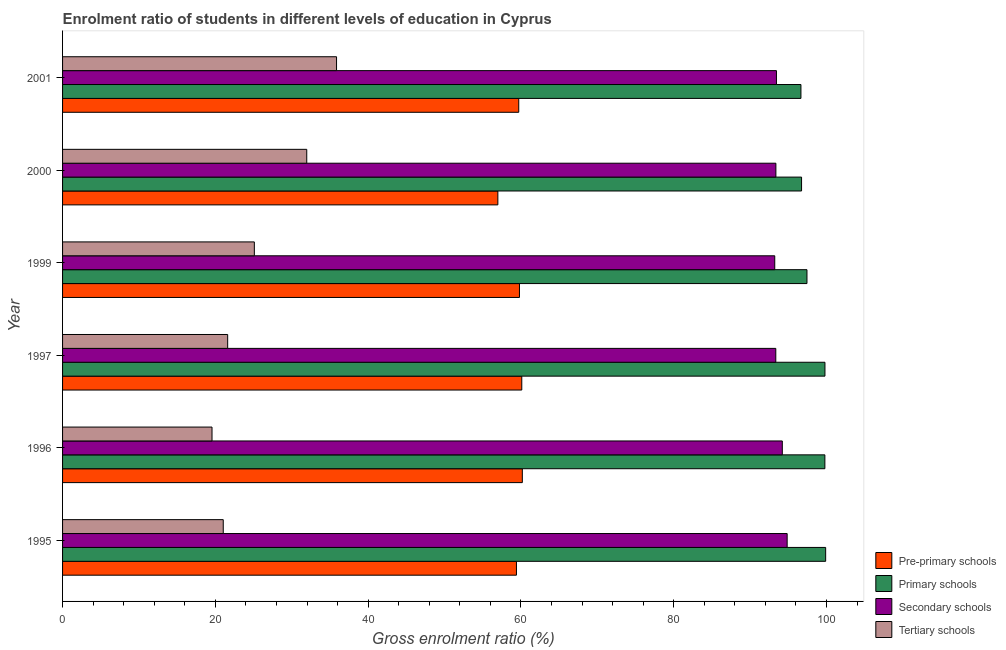How many different coloured bars are there?
Keep it short and to the point. 4. How many groups of bars are there?
Provide a succinct answer. 6. Are the number of bars per tick equal to the number of legend labels?
Provide a short and direct response. Yes. Are the number of bars on each tick of the Y-axis equal?
Keep it short and to the point. Yes. In how many cases, is the number of bars for a given year not equal to the number of legend labels?
Make the answer very short. 0. What is the gross enrolment ratio in pre-primary schools in 1997?
Keep it short and to the point. 60.11. Across all years, what is the maximum gross enrolment ratio in tertiary schools?
Provide a succinct answer. 35.86. Across all years, what is the minimum gross enrolment ratio in tertiary schools?
Offer a very short reply. 19.56. In which year was the gross enrolment ratio in primary schools maximum?
Keep it short and to the point. 1995. What is the total gross enrolment ratio in primary schools in the graph?
Your answer should be very brief. 590.28. What is the difference between the gross enrolment ratio in pre-primary schools in 1997 and that in 2001?
Offer a very short reply. 0.4. What is the difference between the gross enrolment ratio in pre-primary schools in 1999 and the gross enrolment ratio in primary schools in 1996?
Offer a terse response. -39.98. What is the average gross enrolment ratio in secondary schools per year?
Provide a succinct answer. 93.74. In the year 2000, what is the difference between the gross enrolment ratio in primary schools and gross enrolment ratio in pre-primary schools?
Your answer should be compact. 39.75. What is the ratio of the gross enrolment ratio in secondary schools in 1995 to that in 1999?
Keep it short and to the point. 1.02. What is the difference between the highest and the second highest gross enrolment ratio in tertiary schools?
Provide a short and direct response. 3.9. What is the difference between the highest and the lowest gross enrolment ratio in secondary schools?
Ensure brevity in your answer.  1.62. Is the sum of the gross enrolment ratio in tertiary schools in 1996 and 2001 greater than the maximum gross enrolment ratio in pre-primary schools across all years?
Offer a terse response. No. What does the 1st bar from the top in 1996 represents?
Your response must be concise. Tertiary schools. What does the 1st bar from the bottom in 2000 represents?
Offer a terse response. Pre-primary schools. Is it the case that in every year, the sum of the gross enrolment ratio in pre-primary schools and gross enrolment ratio in primary schools is greater than the gross enrolment ratio in secondary schools?
Keep it short and to the point. Yes. Are all the bars in the graph horizontal?
Keep it short and to the point. Yes. Are the values on the major ticks of X-axis written in scientific E-notation?
Give a very brief answer. No. Does the graph contain any zero values?
Keep it short and to the point. No. Where does the legend appear in the graph?
Your response must be concise. Bottom right. How are the legend labels stacked?
Your response must be concise. Vertical. What is the title of the graph?
Make the answer very short. Enrolment ratio of students in different levels of education in Cyprus. What is the label or title of the Y-axis?
Provide a succinct answer. Year. What is the Gross enrolment ratio (%) of Pre-primary schools in 1995?
Offer a terse response. 59.41. What is the Gross enrolment ratio (%) in Primary schools in 1995?
Offer a very short reply. 99.88. What is the Gross enrolment ratio (%) in Secondary schools in 1995?
Offer a very short reply. 94.85. What is the Gross enrolment ratio (%) of Tertiary schools in 1995?
Keep it short and to the point. 21.03. What is the Gross enrolment ratio (%) of Pre-primary schools in 1996?
Your answer should be very brief. 60.18. What is the Gross enrolment ratio (%) of Primary schools in 1996?
Ensure brevity in your answer.  99.78. What is the Gross enrolment ratio (%) of Secondary schools in 1996?
Offer a very short reply. 94.21. What is the Gross enrolment ratio (%) of Tertiary schools in 1996?
Your answer should be compact. 19.56. What is the Gross enrolment ratio (%) of Pre-primary schools in 1997?
Keep it short and to the point. 60.11. What is the Gross enrolment ratio (%) in Primary schools in 1997?
Keep it short and to the point. 99.79. What is the Gross enrolment ratio (%) in Secondary schools in 1997?
Your response must be concise. 93.36. What is the Gross enrolment ratio (%) of Tertiary schools in 1997?
Provide a succinct answer. 21.61. What is the Gross enrolment ratio (%) in Pre-primary schools in 1999?
Your answer should be compact. 59.81. What is the Gross enrolment ratio (%) in Primary schools in 1999?
Keep it short and to the point. 97.44. What is the Gross enrolment ratio (%) in Secondary schools in 1999?
Keep it short and to the point. 93.22. What is the Gross enrolment ratio (%) in Tertiary schools in 1999?
Make the answer very short. 25.1. What is the Gross enrolment ratio (%) of Pre-primary schools in 2000?
Offer a very short reply. 56.98. What is the Gross enrolment ratio (%) in Primary schools in 2000?
Your answer should be very brief. 96.73. What is the Gross enrolment ratio (%) in Secondary schools in 2000?
Provide a short and direct response. 93.37. What is the Gross enrolment ratio (%) in Tertiary schools in 2000?
Keep it short and to the point. 31.96. What is the Gross enrolment ratio (%) in Pre-primary schools in 2001?
Your answer should be compact. 59.71. What is the Gross enrolment ratio (%) in Primary schools in 2001?
Make the answer very short. 96.65. What is the Gross enrolment ratio (%) of Secondary schools in 2001?
Provide a succinct answer. 93.45. What is the Gross enrolment ratio (%) in Tertiary schools in 2001?
Keep it short and to the point. 35.86. Across all years, what is the maximum Gross enrolment ratio (%) of Pre-primary schools?
Offer a very short reply. 60.18. Across all years, what is the maximum Gross enrolment ratio (%) in Primary schools?
Give a very brief answer. 99.88. Across all years, what is the maximum Gross enrolment ratio (%) in Secondary schools?
Ensure brevity in your answer.  94.85. Across all years, what is the maximum Gross enrolment ratio (%) of Tertiary schools?
Offer a terse response. 35.86. Across all years, what is the minimum Gross enrolment ratio (%) of Pre-primary schools?
Offer a terse response. 56.98. Across all years, what is the minimum Gross enrolment ratio (%) of Primary schools?
Your response must be concise. 96.65. Across all years, what is the minimum Gross enrolment ratio (%) of Secondary schools?
Ensure brevity in your answer.  93.22. Across all years, what is the minimum Gross enrolment ratio (%) in Tertiary schools?
Provide a succinct answer. 19.56. What is the total Gross enrolment ratio (%) of Pre-primary schools in the graph?
Offer a terse response. 356.2. What is the total Gross enrolment ratio (%) in Primary schools in the graph?
Ensure brevity in your answer.  590.28. What is the total Gross enrolment ratio (%) of Secondary schools in the graph?
Your answer should be very brief. 562.46. What is the total Gross enrolment ratio (%) of Tertiary schools in the graph?
Keep it short and to the point. 155.14. What is the difference between the Gross enrolment ratio (%) in Pre-primary schools in 1995 and that in 1996?
Provide a succinct answer. -0.77. What is the difference between the Gross enrolment ratio (%) of Primary schools in 1995 and that in 1996?
Provide a succinct answer. 0.1. What is the difference between the Gross enrolment ratio (%) of Secondary schools in 1995 and that in 1996?
Your answer should be very brief. 0.63. What is the difference between the Gross enrolment ratio (%) of Tertiary schools in 1995 and that in 1996?
Provide a succinct answer. 1.47. What is the difference between the Gross enrolment ratio (%) in Pre-primary schools in 1995 and that in 1997?
Keep it short and to the point. -0.7. What is the difference between the Gross enrolment ratio (%) in Primary schools in 1995 and that in 1997?
Offer a very short reply. 0.09. What is the difference between the Gross enrolment ratio (%) in Secondary schools in 1995 and that in 1997?
Provide a short and direct response. 1.49. What is the difference between the Gross enrolment ratio (%) of Tertiary schools in 1995 and that in 1997?
Offer a terse response. -0.58. What is the difference between the Gross enrolment ratio (%) in Pre-primary schools in 1995 and that in 1999?
Provide a short and direct response. -0.4. What is the difference between the Gross enrolment ratio (%) in Primary schools in 1995 and that in 1999?
Your answer should be very brief. 2.45. What is the difference between the Gross enrolment ratio (%) of Secondary schools in 1995 and that in 1999?
Your response must be concise. 1.62. What is the difference between the Gross enrolment ratio (%) of Tertiary schools in 1995 and that in 1999?
Your response must be concise. -4.07. What is the difference between the Gross enrolment ratio (%) of Pre-primary schools in 1995 and that in 2000?
Your answer should be compact. 2.43. What is the difference between the Gross enrolment ratio (%) of Primary schools in 1995 and that in 2000?
Your answer should be very brief. 3.15. What is the difference between the Gross enrolment ratio (%) of Secondary schools in 1995 and that in 2000?
Your answer should be very brief. 1.47. What is the difference between the Gross enrolment ratio (%) of Tertiary schools in 1995 and that in 2000?
Make the answer very short. -10.93. What is the difference between the Gross enrolment ratio (%) of Pre-primary schools in 1995 and that in 2001?
Your answer should be compact. -0.3. What is the difference between the Gross enrolment ratio (%) in Primary schools in 1995 and that in 2001?
Keep it short and to the point. 3.23. What is the difference between the Gross enrolment ratio (%) of Secondary schools in 1995 and that in 2001?
Keep it short and to the point. 1.4. What is the difference between the Gross enrolment ratio (%) of Tertiary schools in 1995 and that in 2001?
Your answer should be compact. -14.83. What is the difference between the Gross enrolment ratio (%) of Pre-primary schools in 1996 and that in 1997?
Your answer should be very brief. 0.07. What is the difference between the Gross enrolment ratio (%) in Primary schools in 1996 and that in 1997?
Offer a very short reply. -0.01. What is the difference between the Gross enrolment ratio (%) in Secondary schools in 1996 and that in 1997?
Your answer should be compact. 0.85. What is the difference between the Gross enrolment ratio (%) of Tertiary schools in 1996 and that in 1997?
Provide a succinct answer. -2.05. What is the difference between the Gross enrolment ratio (%) of Pre-primary schools in 1996 and that in 1999?
Your answer should be compact. 0.37. What is the difference between the Gross enrolment ratio (%) of Primary schools in 1996 and that in 1999?
Make the answer very short. 2.35. What is the difference between the Gross enrolment ratio (%) of Tertiary schools in 1996 and that in 1999?
Provide a short and direct response. -5.54. What is the difference between the Gross enrolment ratio (%) of Pre-primary schools in 1996 and that in 2000?
Ensure brevity in your answer.  3.2. What is the difference between the Gross enrolment ratio (%) in Primary schools in 1996 and that in 2000?
Ensure brevity in your answer.  3.05. What is the difference between the Gross enrolment ratio (%) of Secondary schools in 1996 and that in 2000?
Provide a succinct answer. 0.84. What is the difference between the Gross enrolment ratio (%) of Tertiary schools in 1996 and that in 2000?
Your answer should be compact. -12.4. What is the difference between the Gross enrolment ratio (%) of Pre-primary schools in 1996 and that in 2001?
Ensure brevity in your answer.  0.47. What is the difference between the Gross enrolment ratio (%) of Primary schools in 1996 and that in 2001?
Offer a terse response. 3.13. What is the difference between the Gross enrolment ratio (%) of Secondary schools in 1996 and that in 2001?
Offer a very short reply. 0.77. What is the difference between the Gross enrolment ratio (%) in Tertiary schools in 1996 and that in 2001?
Your answer should be very brief. -16.3. What is the difference between the Gross enrolment ratio (%) of Pre-primary schools in 1997 and that in 1999?
Ensure brevity in your answer.  0.3. What is the difference between the Gross enrolment ratio (%) of Primary schools in 1997 and that in 1999?
Provide a short and direct response. 2.35. What is the difference between the Gross enrolment ratio (%) of Secondary schools in 1997 and that in 1999?
Ensure brevity in your answer.  0.14. What is the difference between the Gross enrolment ratio (%) of Tertiary schools in 1997 and that in 1999?
Your answer should be compact. -3.49. What is the difference between the Gross enrolment ratio (%) in Pre-primary schools in 1997 and that in 2000?
Offer a very short reply. 3.13. What is the difference between the Gross enrolment ratio (%) in Primary schools in 1997 and that in 2000?
Your answer should be compact. 3.06. What is the difference between the Gross enrolment ratio (%) in Secondary schools in 1997 and that in 2000?
Give a very brief answer. -0.01. What is the difference between the Gross enrolment ratio (%) of Tertiary schools in 1997 and that in 2000?
Offer a terse response. -10.35. What is the difference between the Gross enrolment ratio (%) in Pre-primary schools in 1997 and that in 2001?
Keep it short and to the point. 0.4. What is the difference between the Gross enrolment ratio (%) of Primary schools in 1997 and that in 2001?
Keep it short and to the point. 3.14. What is the difference between the Gross enrolment ratio (%) of Secondary schools in 1997 and that in 2001?
Make the answer very short. -0.09. What is the difference between the Gross enrolment ratio (%) in Tertiary schools in 1997 and that in 2001?
Your answer should be compact. -14.25. What is the difference between the Gross enrolment ratio (%) of Pre-primary schools in 1999 and that in 2000?
Give a very brief answer. 2.83. What is the difference between the Gross enrolment ratio (%) in Primary schools in 1999 and that in 2000?
Make the answer very short. 0.71. What is the difference between the Gross enrolment ratio (%) of Secondary schools in 1999 and that in 2000?
Provide a short and direct response. -0.15. What is the difference between the Gross enrolment ratio (%) in Tertiary schools in 1999 and that in 2000?
Offer a very short reply. -6.86. What is the difference between the Gross enrolment ratio (%) of Pre-primary schools in 1999 and that in 2001?
Offer a terse response. 0.09. What is the difference between the Gross enrolment ratio (%) of Primary schools in 1999 and that in 2001?
Your answer should be very brief. 0.79. What is the difference between the Gross enrolment ratio (%) in Secondary schools in 1999 and that in 2001?
Give a very brief answer. -0.22. What is the difference between the Gross enrolment ratio (%) in Tertiary schools in 1999 and that in 2001?
Offer a very short reply. -10.76. What is the difference between the Gross enrolment ratio (%) of Pre-primary schools in 2000 and that in 2001?
Keep it short and to the point. -2.74. What is the difference between the Gross enrolment ratio (%) in Primary schools in 2000 and that in 2001?
Provide a succinct answer. 0.08. What is the difference between the Gross enrolment ratio (%) in Secondary schools in 2000 and that in 2001?
Provide a succinct answer. -0.07. What is the difference between the Gross enrolment ratio (%) in Tertiary schools in 2000 and that in 2001?
Your response must be concise. -3.9. What is the difference between the Gross enrolment ratio (%) of Pre-primary schools in 1995 and the Gross enrolment ratio (%) of Primary schools in 1996?
Provide a short and direct response. -40.37. What is the difference between the Gross enrolment ratio (%) in Pre-primary schools in 1995 and the Gross enrolment ratio (%) in Secondary schools in 1996?
Provide a succinct answer. -34.8. What is the difference between the Gross enrolment ratio (%) of Pre-primary schools in 1995 and the Gross enrolment ratio (%) of Tertiary schools in 1996?
Provide a succinct answer. 39.85. What is the difference between the Gross enrolment ratio (%) in Primary schools in 1995 and the Gross enrolment ratio (%) in Secondary schools in 1996?
Give a very brief answer. 5.67. What is the difference between the Gross enrolment ratio (%) in Primary schools in 1995 and the Gross enrolment ratio (%) in Tertiary schools in 1996?
Provide a succinct answer. 80.32. What is the difference between the Gross enrolment ratio (%) in Secondary schools in 1995 and the Gross enrolment ratio (%) in Tertiary schools in 1996?
Offer a very short reply. 75.28. What is the difference between the Gross enrolment ratio (%) in Pre-primary schools in 1995 and the Gross enrolment ratio (%) in Primary schools in 1997?
Give a very brief answer. -40.38. What is the difference between the Gross enrolment ratio (%) in Pre-primary schools in 1995 and the Gross enrolment ratio (%) in Secondary schools in 1997?
Your answer should be compact. -33.95. What is the difference between the Gross enrolment ratio (%) of Pre-primary schools in 1995 and the Gross enrolment ratio (%) of Tertiary schools in 1997?
Provide a short and direct response. 37.8. What is the difference between the Gross enrolment ratio (%) in Primary schools in 1995 and the Gross enrolment ratio (%) in Secondary schools in 1997?
Your answer should be very brief. 6.53. What is the difference between the Gross enrolment ratio (%) in Primary schools in 1995 and the Gross enrolment ratio (%) in Tertiary schools in 1997?
Your answer should be compact. 78.27. What is the difference between the Gross enrolment ratio (%) in Secondary schools in 1995 and the Gross enrolment ratio (%) in Tertiary schools in 1997?
Keep it short and to the point. 73.23. What is the difference between the Gross enrolment ratio (%) in Pre-primary schools in 1995 and the Gross enrolment ratio (%) in Primary schools in 1999?
Make the answer very short. -38.03. What is the difference between the Gross enrolment ratio (%) in Pre-primary schools in 1995 and the Gross enrolment ratio (%) in Secondary schools in 1999?
Provide a short and direct response. -33.81. What is the difference between the Gross enrolment ratio (%) of Pre-primary schools in 1995 and the Gross enrolment ratio (%) of Tertiary schools in 1999?
Ensure brevity in your answer.  34.31. What is the difference between the Gross enrolment ratio (%) in Primary schools in 1995 and the Gross enrolment ratio (%) in Secondary schools in 1999?
Provide a succinct answer. 6.66. What is the difference between the Gross enrolment ratio (%) in Primary schools in 1995 and the Gross enrolment ratio (%) in Tertiary schools in 1999?
Give a very brief answer. 74.78. What is the difference between the Gross enrolment ratio (%) in Secondary schools in 1995 and the Gross enrolment ratio (%) in Tertiary schools in 1999?
Your response must be concise. 69.74. What is the difference between the Gross enrolment ratio (%) in Pre-primary schools in 1995 and the Gross enrolment ratio (%) in Primary schools in 2000?
Ensure brevity in your answer.  -37.32. What is the difference between the Gross enrolment ratio (%) in Pre-primary schools in 1995 and the Gross enrolment ratio (%) in Secondary schools in 2000?
Offer a very short reply. -33.96. What is the difference between the Gross enrolment ratio (%) of Pre-primary schools in 1995 and the Gross enrolment ratio (%) of Tertiary schools in 2000?
Keep it short and to the point. 27.45. What is the difference between the Gross enrolment ratio (%) in Primary schools in 1995 and the Gross enrolment ratio (%) in Secondary schools in 2000?
Ensure brevity in your answer.  6.51. What is the difference between the Gross enrolment ratio (%) in Primary schools in 1995 and the Gross enrolment ratio (%) in Tertiary schools in 2000?
Your answer should be compact. 67.92. What is the difference between the Gross enrolment ratio (%) in Secondary schools in 1995 and the Gross enrolment ratio (%) in Tertiary schools in 2000?
Provide a succinct answer. 62.88. What is the difference between the Gross enrolment ratio (%) of Pre-primary schools in 1995 and the Gross enrolment ratio (%) of Primary schools in 2001?
Give a very brief answer. -37.24. What is the difference between the Gross enrolment ratio (%) in Pre-primary schools in 1995 and the Gross enrolment ratio (%) in Secondary schools in 2001?
Keep it short and to the point. -34.03. What is the difference between the Gross enrolment ratio (%) in Pre-primary schools in 1995 and the Gross enrolment ratio (%) in Tertiary schools in 2001?
Your answer should be compact. 23.55. What is the difference between the Gross enrolment ratio (%) in Primary schools in 1995 and the Gross enrolment ratio (%) in Secondary schools in 2001?
Your answer should be compact. 6.44. What is the difference between the Gross enrolment ratio (%) in Primary schools in 1995 and the Gross enrolment ratio (%) in Tertiary schools in 2001?
Your answer should be very brief. 64.02. What is the difference between the Gross enrolment ratio (%) in Secondary schools in 1995 and the Gross enrolment ratio (%) in Tertiary schools in 2001?
Keep it short and to the point. 58.98. What is the difference between the Gross enrolment ratio (%) of Pre-primary schools in 1996 and the Gross enrolment ratio (%) of Primary schools in 1997?
Offer a terse response. -39.61. What is the difference between the Gross enrolment ratio (%) of Pre-primary schools in 1996 and the Gross enrolment ratio (%) of Secondary schools in 1997?
Provide a succinct answer. -33.18. What is the difference between the Gross enrolment ratio (%) in Pre-primary schools in 1996 and the Gross enrolment ratio (%) in Tertiary schools in 1997?
Give a very brief answer. 38.57. What is the difference between the Gross enrolment ratio (%) of Primary schools in 1996 and the Gross enrolment ratio (%) of Secondary schools in 1997?
Ensure brevity in your answer.  6.42. What is the difference between the Gross enrolment ratio (%) of Primary schools in 1996 and the Gross enrolment ratio (%) of Tertiary schools in 1997?
Make the answer very short. 78.17. What is the difference between the Gross enrolment ratio (%) of Secondary schools in 1996 and the Gross enrolment ratio (%) of Tertiary schools in 1997?
Offer a terse response. 72.6. What is the difference between the Gross enrolment ratio (%) of Pre-primary schools in 1996 and the Gross enrolment ratio (%) of Primary schools in 1999?
Your response must be concise. -37.26. What is the difference between the Gross enrolment ratio (%) of Pre-primary schools in 1996 and the Gross enrolment ratio (%) of Secondary schools in 1999?
Make the answer very short. -33.04. What is the difference between the Gross enrolment ratio (%) of Pre-primary schools in 1996 and the Gross enrolment ratio (%) of Tertiary schools in 1999?
Your answer should be compact. 35.08. What is the difference between the Gross enrolment ratio (%) of Primary schools in 1996 and the Gross enrolment ratio (%) of Secondary schools in 1999?
Your answer should be compact. 6.56. What is the difference between the Gross enrolment ratio (%) in Primary schools in 1996 and the Gross enrolment ratio (%) in Tertiary schools in 1999?
Your answer should be compact. 74.68. What is the difference between the Gross enrolment ratio (%) in Secondary schools in 1996 and the Gross enrolment ratio (%) in Tertiary schools in 1999?
Your response must be concise. 69.11. What is the difference between the Gross enrolment ratio (%) of Pre-primary schools in 1996 and the Gross enrolment ratio (%) of Primary schools in 2000?
Provide a short and direct response. -36.55. What is the difference between the Gross enrolment ratio (%) of Pre-primary schools in 1996 and the Gross enrolment ratio (%) of Secondary schools in 2000?
Your response must be concise. -33.19. What is the difference between the Gross enrolment ratio (%) of Pre-primary schools in 1996 and the Gross enrolment ratio (%) of Tertiary schools in 2000?
Keep it short and to the point. 28.22. What is the difference between the Gross enrolment ratio (%) of Primary schools in 1996 and the Gross enrolment ratio (%) of Secondary schools in 2000?
Keep it short and to the point. 6.41. What is the difference between the Gross enrolment ratio (%) of Primary schools in 1996 and the Gross enrolment ratio (%) of Tertiary schools in 2000?
Your response must be concise. 67.82. What is the difference between the Gross enrolment ratio (%) in Secondary schools in 1996 and the Gross enrolment ratio (%) in Tertiary schools in 2000?
Offer a terse response. 62.25. What is the difference between the Gross enrolment ratio (%) in Pre-primary schools in 1996 and the Gross enrolment ratio (%) in Primary schools in 2001?
Your response must be concise. -36.47. What is the difference between the Gross enrolment ratio (%) in Pre-primary schools in 1996 and the Gross enrolment ratio (%) in Secondary schools in 2001?
Offer a very short reply. -33.26. What is the difference between the Gross enrolment ratio (%) in Pre-primary schools in 1996 and the Gross enrolment ratio (%) in Tertiary schools in 2001?
Make the answer very short. 24.32. What is the difference between the Gross enrolment ratio (%) in Primary schools in 1996 and the Gross enrolment ratio (%) in Secondary schools in 2001?
Your answer should be compact. 6.34. What is the difference between the Gross enrolment ratio (%) in Primary schools in 1996 and the Gross enrolment ratio (%) in Tertiary schools in 2001?
Keep it short and to the point. 63.92. What is the difference between the Gross enrolment ratio (%) of Secondary schools in 1996 and the Gross enrolment ratio (%) of Tertiary schools in 2001?
Give a very brief answer. 58.35. What is the difference between the Gross enrolment ratio (%) in Pre-primary schools in 1997 and the Gross enrolment ratio (%) in Primary schools in 1999?
Ensure brevity in your answer.  -37.33. What is the difference between the Gross enrolment ratio (%) in Pre-primary schools in 1997 and the Gross enrolment ratio (%) in Secondary schools in 1999?
Ensure brevity in your answer.  -33.11. What is the difference between the Gross enrolment ratio (%) of Pre-primary schools in 1997 and the Gross enrolment ratio (%) of Tertiary schools in 1999?
Make the answer very short. 35.01. What is the difference between the Gross enrolment ratio (%) of Primary schools in 1997 and the Gross enrolment ratio (%) of Secondary schools in 1999?
Make the answer very short. 6.57. What is the difference between the Gross enrolment ratio (%) in Primary schools in 1997 and the Gross enrolment ratio (%) in Tertiary schools in 1999?
Keep it short and to the point. 74.69. What is the difference between the Gross enrolment ratio (%) in Secondary schools in 1997 and the Gross enrolment ratio (%) in Tertiary schools in 1999?
Ensure brevity in your answer.  68.26. What is the difference between the Gross enrolment ratio (%) of Pre-primary schools in 1997 and the Gross enrolment ratio (%) of Primary schools in 2000?
Your answer should be compact. -36.62. What is the difference between the Gross enrolment ratio (%) of Pre-primary schools in 1997 and the Gross enrolment ratio (%) of Secondary schools in 2000?
Make the answer very short. -33.26. What is the difference between the Gross enrolment ratio (%) in Pre-primary schools in 1997 and the Gross enrolment ratio (%) in Tertiary schools in 2000?
Give a very brief answer. 28.15. What is the difference between the Gross enrolment ratio (%) of Primary schools in 1997 and the Gross enrolment ratio (%) of Secondary schools in 2000?
Offer a terse response. 6.42. What is the difference between the Gross enrolment ratio (%) in Primary schools in 1997 and the Gross enrolment ratio (%) in Tertiary schools in 2000?
Your answer should be compact. 67.83. What is the difference between the Gross enrolment ratio (%) in Secondary schools in 1997 and the Gross enrolment ratio (%) in Tertiary schools in 2000?
Provide a short and direct response. 61.4. What is the difference between the Gross enrolment ratio (%) in Pre-primary schools in 1997 and the Gross enrolment ratio (%) in Primary schools in 2001?
Make the answer very short. -36.54. What is the difference between the Gross enrolment ratio (%) in Pre-primary schools in 1997 and the Gross enrolment ratio (%) in Secondary schools in 2001?
Make the answer very short. -33.34. What is the difference between the Gross enrolment ratio (%) of Pre-primary schools in 1997 and the Gross enrolment ratio (%) of Tertiary schools in 2001?
Your response must be concise. 24.25. What is the difference between the Gross enrolment ratio (%) of Primary schools in 1997 and the Gross enrolment ratio (%) of Secondary schools in 2001?
Make the answer very short. 6.35. What is the difference between the Gross enrolment ratio (%) of Primary schools in 1997 and the Gross enrolment ratio (%) of Tertiary schools in 2001?
Your response must be concise. 63.93. What is the difference between the Gross enrolment ratio (%) of Secondary schools in 1997 and the Gross enrolment ratio (%) of Tertiary schools in 2001?
Provide a short and direct response. 57.5. What is the difference between the Gross enrolment ratio (%) in Pre-primary schools in 1999 and the Gross enrolment ratio (%) in Primary schools in 2000?
Provide a succinct answer. -36.92. What is the difference between the Gross enrolment ratio (%) of Pre-primary schools in 1999 and the Gross enrolment ratio (%) of Secondary schools in 2000?
Your answer should be compact. -33.56. What is the difference between the Gross enrolment ratio (%) in Pre-primary schools in 1999 and the Gross enrolment ratio (%) in Tertiary schools in 2000?
Make the answer very short. 27.84. What is the difference between the Gross enrolment ratio (%) in Primary schools in 1999 and the Gross enrolment ratio (%) in Secondary schools in 2000?
Offer a terse response. 4.07. What is the difference between the Gross enrolment ratio (%) of Primary schools in 1999 and the Gross enrolment ratio (%) of Tertiary schools in 2000?
Keep it short and to the point. 65.47. What is the difference between the Gross enrolment ratio (%) of Secondary schools in 1999 and the Gross enrolment ratio (%) of Tertiary schools in 2000?
Provide a succinct answer. 61.26. What is the difference between the Gross enrolment ratio (%) in Pre-primary schools in 1999 and the Gross enrolment ratio (%) in Primary schools in 2001?
Your response must be concise. -36.84. What is the difference between the Gross enrolment ratio (%) of Pre-primary schools in 1999 and the Gross enrolment ratio (%) of Secondary schools in 2001?
Offer a terse response. -33.64. What is the difference between the Gross enrolment ratio (%) in Pre-primary schools in 1999 and the Gross enrolment ratio (%) in Tertiary schools in 2001?
Provide a succinct answer. 23.94. What is the difference between the Gross enrolment ratio (%) of Primary schools in 1999 and the Gross enrolment ratio (%) of Secondary schools in 2001?
Your answer should be very brief. 3.99. What is the difference between the Gross enrolment ratio (%) of Primary schools in 1999 and the Gross enrolment ratio (%) of Tertiary schools in 2001?
Offer a very short reply. 61.57. What is the difference between the Gross enrolment ratio (%) in Secondary schools in 1999 and the Gross enrolment ratio (%) in Tertiary schools in 2001?
Your response must be concise. 57.36. What is the difference between the Gross enrolment ratio (%) of Pre-primary schools in 2000 and the Gross enrolment ratio (%) of Primary schools in 2001?
Keep it short and to the point. -39.67. What is the difference between the Gross enrolment ratio (%) in Pre-primary schools in 2000 and the Gross enrolment ratio (%) in Secondary schools in 2001?
Make the answer very short. -36.47. What is the difference between the Gross enrolment ratio (%) of Pre-primary schools in 2000 and the Gross enrolment ratio (%) of Tertiary schools in 2001?
Give a very brief answer. 21.11. What is the difference between the Gross enrolment ratio (%) in Primary schools in 2000 and the Gross enrolment ratio (%) in Secondary schools in 2001?
Offer a terse response. 3.29. What is the difference between the Gross enrolment ratio (%) of Primary schools in 2000 and the Gross enrolment ratio (%) of Tertiary schools in 2001?
Give a very brief answer. 60.87. What is the difference between the Gross enrolment ratio (%) in Secondary schools in 2000 and the Gross enrolment ratio (%) in Tertiary schools in 2001?
Your answer should be compact. 57.51. What is the average Gross enrolment ratio (%) of Pre-primary schools per year?
Offer a terse response. 59.37. What is the average Gross enrolment ratio (%) in Primary schools per year?
Offer a very short reply. 98.38. What is the average Gross enrolment ratio (%) of Secondary schools per year?
Your response must be concise. 93.74. What is the average Gross enrolment ratio (%) in Tertiary schools per year?
Offer a very short reply. 25.86. In the year 1995, what is the difference between the Gross enrolment ratio (%) of Pre-primary schools and Gross enrolment ratio (%) of Primary schools?
Provide a succinct answer. -40.47. In the year 1995, what is the difference between the Gross enrolment ratio (%) of Pre-primary schools and Gross enrolment ratio (%) of Secondary schools?
Offer a terse response. -35.43. In the year 1995, what is the difference between the Gross enrolment ratio (%) of Pre-primary schools and Gross enrolment ratio (%) of Tertiary schools?
Keep it short and to the point. 38.38. In the year 1995, what is the difference between the Gross enrolment ratio (%) in Primary schools and Gross enrolment ratio (%) in Secondary schools?
Provide a short and direct response. 5.04. In the year 1995, what is the difference between the Gross enrolment ratio (%) in Primary schools and Gross enrolment ratio (%) in Tertiary schools?
Your answer should be compact. 78.85. In the year 1995, what is the difference between the Gross enrolment ratio (%) in Secondary schools and Gross enrolment ratio (%) in Tertiary schools?
Your answer should be very brief. 73.81. In the year 1996, what is the difference between the Gross enrolment ratio (%) in Pre-primary schools and Gross enrolment ratio (%) in Primary schools?
Keep it short and to the point. -39.6. In the year 1996, what is the difference between the Gross enrolment ratio (%) in Pre-primary schools and Gross enrolment ratio (%) in Secondary schools?
Your answer should be very brief. -34.03. In the year 1996, what is the difference between the Gross enrolment ratio (%) of Pre-primary schools and Gross enrolment ratio (%) of Tertiary schools?
Make the answer very short. 40.62. In the year 1996, what is the difference between the Gross enrolment ratio (%) in Primary schools and Gross enrolment ratio (%) in Secondary schools?
Offer a terse response. 5.57. In the year 1996, what is the difference between the Gross enrolment ratio (%) in Primary schools and Gross enrolment ratio (%) in Tertiary schools?
Offer a terse response. 80.22. In the year 1996, what is the difference between the Gross enrolment ratio (%) in Secondary schools and Gross enrolment ratio (%) in Tertiary schools?
Your answer should be very brief. 74.65. In the year 1997, what is the difference between the Gross enrolment ratio (%) in Pre-primary schools and Gross enrolment ratio (%) in Primary schools?
Ensure brevity in your answer.  -39.68. In the year 1997, what is the difference between the Gross enrolment ratio (%) in Pre-primary schools and Gross enrolment ratio (%) in Secondary schools?
Keep it short and to the point. -33.25. In the year 1997, what is the difference between the Gross enrolment ratio (%) of Pre-primary schools and Gross enrolment ratio (%) of Tertiary schools?
Your response must be concise. 38.5. In the year 1997, what is the difference between the Gross enrolment ratio (%) in Primary schools and Gross enrolment ratio (%) in Secondary schools?
Your response must be concise. 6.43. In the year 1997, what is the difference between the Gross enrolment ratio (%) in Primary schools and Gross enrolment ratio (%) in Tertiary schools?
Provide a succinct answer. 78.18. In the year 1997, what is the difference between the Gross enrolment ratio (%) of Secondary schools and Gross enrolment ratio (%) of Tertiary schools?
Make the answer very short. 71.75. In the year 1999, what is the difference between the Gross enrolment ratio (%) of Pre-primary schools and Gross enrolment ratio (%) of Primary schools?
Provide a succinct answer. -37.63. In the year 1999, what is the difference between the Gross enrolment ratio (%) in Pre-primary schools and Gross enrolment ratio (%) in Secondary schools?
Your answer should be very brief. -33.42. In the year 1999, what is the difference between the Gross enrolment ratio (%) in Pre-primary schools and Gross enrolment ratio (%) in Tertiary schools?
Give a very brief answer. 34.7. In the year 1999, what is the difference between the Gross enrolment ratio (%) in Primary schools and Gross enrolment ratio (%) in Secondary schools?
Give a very brief answer. 4.22. In the year 1999, what is the difference between the Gross enrolment ratio (%) of Primary schools and Gross enrolment ratio (%) of Tertiary schools?
Keep it short and to the point. 72.34. In the year 1999, what is the difference between the Gross enrolment ratio (%) in Secondary schools and Gross enrolment ratio (%) in Tertiary schools?
Your answer should be very brief. 68.12. In the year 2000, what is the difference between the Gross enrolment ratio (%) of Pre-primary schools and Gross enrolment ratio (%) of Primary schools?
Your answer should be very brief. -39.75. In the year 2000, what is the difference between the Gross enrolment ratio (%) of Pre-primary schools and Gross enrolment ratio (%) of Secondary schools?
Your answer should be very brief. -36.39. In the year 2000, what is the difference between the Gross enrolment ratio (%) of Pre-primary schools and Gross enrolment ratio (%) of Tertiary schools?
Offer a terse response. 25.01. In the year 2000, what is the difference between the Gross enrolment ratio (%) in Primary schools and Gross enrolment ratio (%) in Secondary schools?
Provide a short and direct response. 3.36. In the year 2000, what is the difference between the Gross enrolment ratio (%) of Primary schools and Gross enrolment ratio (%) of Tertiary schools?
Keep it short and to the point. 64.77. In the year 2000, what is the difference between the Gross enrolment ratio (%) in Secondary schools and Gross enrolment ratio (%) in Tertiary schools?
Offer a very short reply. 61.41. In the year 2001, what is the difference between the Gross enrolment ratio (%) in Pre-primary schools and Gross enrolment ratio (%) in Primary schools?
Ensure brevity in your answer.  -36.94. In the year 2001, what is the difference between the Gross enrolment ratio (%) in Pre-primary schools and Gross enrolment ratio (%) in Secondary schools?
Your response must be concise. -33.73. In the year 2001, what is the difference between the Gross enrolment ratio (%) of Pre-primary schools and Gross enrolment ratio (%) of Tertiary schools?
Keep it short and to the point. 23.85. In the year 2001, what is the difference between the Gross enrolment ratio (%) in Primary schools and Gross enrolment ratio (%) in Secondary schools?
Provide a succinct answer. 3.2. In the year 2001, what is the difference between the Gross enrolment ratio (%) in Primary schools and Gross enrolment ratio (%) in Tertiary schools?
Your response must be concise. 60.79. In the year 2001, what is the difference between the Gross enrolment ratio (%) of Secondary schools and Gross enrolment ratio (%) of Tertiary schools?
Offer a very short reply. 57.58. What is the ratio of the Gross enrolment ratio (%) of Pre-primary schools in 1995 to that in 1996?
Provide a succinct answer. 0.99. What is the ratio of the Gross enrolment ratio (%) in Primary schools in 1995 to that in 1996?
Ensure brevity in your answer.  1. What is the ratio of the Gross enrolment ratio (%) in Secondary schools in 1995 to that in 1996?
Make the answer very short. 1.01. What is the ratio of the Gross enrolment ratio (%) of Tertiary schools in 1995 to that in 1996?
Keep it short and to the point. 1.08. What is the ratio of the Gross enrolment ratio (%) of Pre-primary schools in 1995 to that in 1997?
Your response must be concise. 0.99. What is the ratio of the Gross enrolment ratio (%) of Primary schools in 1995 to that in 1997?
Provide a succinct answer. 1. What is the ratio of the Gross enrolment ratio (%) in Secondary schools in 1995 to that in 1997?
Make the answer very short. 1.02. What is the ratio of the Gross enrolment ratio (%) in Tertiary schools in 1995 to that in 1997?
Provide a short and direct response. 0.97. What is the ratio of the Gross enrolment ratio (%) in Pre-primary schools in 1995 to that in 1999?
Ensure brevity in your answer.  0.99. What is the ratio of the Gross enrolment ratio (%) of Primary schools in 1995 to that in 1999?
Your answer should be very brief. 1.03. What is the ratio of the Gross enrolment ratio (%) in Secondary schools in 1995 to that in 1999?
Provide a succinct answer. 1.02. What is the ratio of the Gross enrolment ratio (%) of Tertiary schools in 1995 to that in 1999?
Provide a short and direct response. 0.84. What is the ratio of the Gross enrolment ratio (%) of Pre-primary schools in 1995 to that in 2000?
Keep it short and to the point. 1.04. What is the ratio of the Gross enrolment ratio (%) of Primary schools in 1995 to that in 2000?
Your answer should be compact. 1.03. What is the ratio of the Gross enrolment ratio (%) of Secondary schools in 1995 to that in 2000?
Offer a very short reply. 1.02. What is the ratio of the Gross enrolment ratio (%) of Tertiary schools in 1995 to that in 2000?
Your response must be concise. 0.66. What is the ratio of the Gross enrolment ratio (%) of Primary schools in 1995 to that in 2001?
Your response must be concise. 1.03. What is the ratio of the Gross enrolment ratio (%) in Tertiary schools in 1995 to that in 2001?
Provide a short and direct response. 0.59. What is the ratio of the Gross enrolment ratio (%) of Secondary schools in 1996 to that in 1997?
Provide a succinct answer. 1.01. What is the ratio of the Gross enrolment ratio (%) of Tertiary schools in 1996 to that in 1997?
Make the answer very short. 0.91. What is the ratio of the Gross enrolment ratio (%) in Primary schools in 1996 to that in 1999?
Your answer should be compact. 1.02. What is the ratio of the Gross enrolment ratio (%) in Secondary schools in 1996 to that in 1999?
Your answer should be compact. 1.01. What is the ratio of the Gross enrolment ratio (%) of Tertiary schools in 1996 to that in 1999?
Your response must be concise. 0.78. What is the ratio of the Gross enrolment ratio (%) of Pre-primary schools in 1996 to that in 2000?
Ensure brevity in your answer.  1.06. What is the ratio of the Gross enrolment ratio (%) of Primary schools in 1996 to that in 2000?
Your response must be concise. 1.03. What is the ratio of the Gross enrolment ratio (%) of Tertiary schools in 1996 to that in 2000?
Your response must be concise. 0.61. What is the ratio of the Gross enrolment ratio (%) in Pre-primary schools in 1996 to that in 2001?
Your response must be concise. 1.01. What is the ratio of the Gross enrolment ratio (%) of Primary schools in 1996 to that in 2001?
Ensure brevity in your answer.  1.03. What is the ratio of the Gross enrolment ratio (%) of Secondary schools in 1996 to that in 2001?
Provide a short and direct response. 1.01. What is the ratio of the Gross enrolment ratio (%) in Tertiary schools in 1996 to that in 2001?
Make the answer very short. 0.55. What is the ratio of the Gross enrolment ratio (%) of Pre-primary schools in 1997 to that in 1999?
Ensure brevity in your answer.  1. What is the ratio of the Gross enrolment ratio (%) of Primary schools in 1997 to that in 1999?
Ensure brevity in your answer.  1.02. What is the ratio of the Gross enrolment ratio (%) of Tertiary schools in 1997 to that in 1999?
Ensure brevity in your answer.  0.86. What is the ratio of the Gross enrolment ratio (%) in Pre-primary schools in 1997 to that in 2000?
Your answer should be very brief. 1.05. What is the ratio of the Gross enrolment ratio (%) in Primary schools in 1997 to that in 2000?
Offer a terse response. 1.03. What is the ratio of the Gross enrolment ratio (%) of Secondary schools in 1997 to that in 2000?
Your answer should be very brief. 1. What is the ratio of the Gross enrolment ratio (%) in Tertiary schools in 1997 to that in 2000?
Provide a short and direct response. 0.68. What is the ratio of the Gross enrolment ratio (%) of Pre-primary schools in 1997 to that in 2001?
Make the answer very short. 1.01. What is the ratio of the Gross enrolment ratio (%) of Primary schools in 1997 to that in 2001?
Provide a short and direct response. 1.03. What is the ratio of the Gross enrolment ratio (%) of Tertiary schools in 1997 to that in 2001?
Provide a succinct answer. 0.6. What is the ratio of the Gross enrolment ratio (%) in Pre-primary schools in 1999 to that in 2000?
Give a very brief answer. 1.05. What is the ratio of the Gross enrolment ratio (%) of Primary schools in 1999 to that in 2000?
Ensure brevity in your answer.  1.01. What is the ratio of the Gross enrolment ratio (%) in Secondary schools in 1999 to that in 2000?
Provide a succinct answer. 1. What is the ratio of the Gross enrolment ratio (%) in Tertiary schools in 1999 to that in 2000?
Provide a succinct answer. 0.79. What is the ratio of the Gross enrolment ratio (%) in Primary schools in 1999 to that in 2001?
Offer a terse response. 1.01. What is the ratio of the Gross enrolment ratio (%) of Secondary schools in 1999 to that in 2001?
Make the answer very short. 1. What is the ratio of the Gross enrolment ratio (%) in Tertiary schools in 1999 to that in 2001?
Your answer should be compact. 0.7. What is the ratio of the Gross enrolment ratio (%) of Pre-primary schools in 2000 to that in 2001?
Make the answer very short. 0.95. What is the ratio of the Gross enrolment ratio (%) of Secondary schools in 2000 to that in 2001?
Provide a succinct answer. 1. What is the ratio of the Gross enrolment ratio (%) in Tertiary schools in 2000 to that in 2001?
Offer a terse response. 0.89. What is the difference between the highest and the second highest Gross enrolment ratio (%) of Pre-primary schools?
Ensure brevity in your answer.  0.07. What is the difference between the highest and the second highest Gross enrolment ratio (%) of Primary schools?
Provide a short and direct response. 0.09. What is the difference between the highest and the second highest Gross enrolment ratio (%) in Secondary schools?
Offer a terse response. 0.63. What is the difference between the highest and the second highest Gross enrolment ratio (%) in Tertiary schools?
Provide a short and direct response. 3.9. What is the difference between the highest and the lowest Gross enrolment ratio (%) of Pre-primary schools?
Your answer should be compact. 3.2. What is the difference between the highest and the lowest Gross enrolment ratio (%) in Primary schools?
Your response must be concise. 3.23. What is the difference between the highest and the lowest Gross enrolment ratio (%) of Secondary schools?
Your answer should be compact. 1.62. What is the difference between the highest and the lowest Gross enrolment ratio (%) of Tertiary schools?
Make the answer very short. 16.3. 